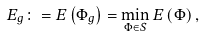Convert formula to latex. <formula><loc_0><loc_0><loc_500><loc_500>E _ { g } \colon = E \left ( \Phi _ { g } \right ) = \min _ { \Phi \in S } E \left ( \Phi \right ) ,</formula> 